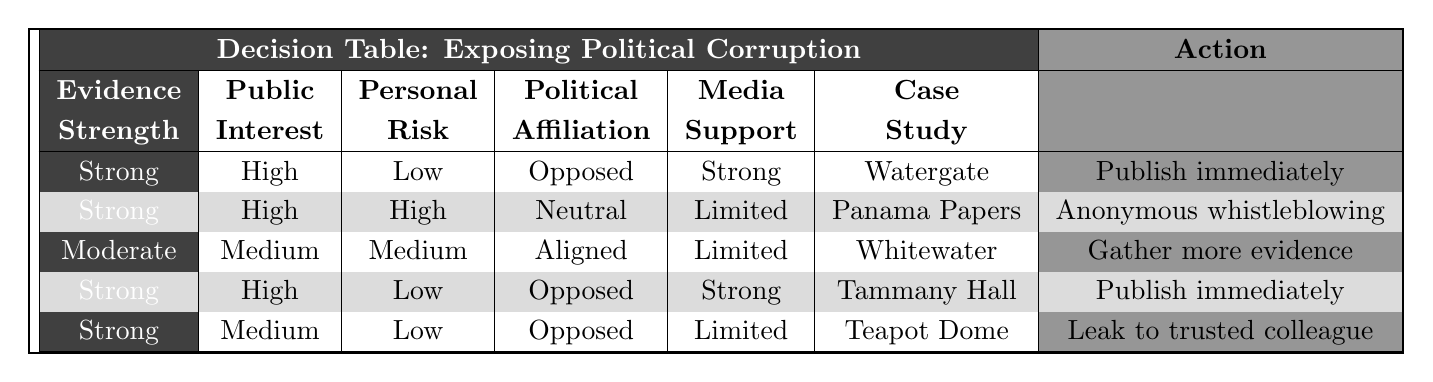What action is suggested for strong evidence, high public interest, and low personal risk with an opposed political affiliation and strong media support? According to the table, the conditions for the desired action are matched in the first row, which indicates that the action suggested in this case is to publish immediately.
Answer: Publish immediately Is the action for moderate evidence, medium public interest, and medium personal risk with aligned political affiliation and limited media support to gather more evidence? The table clearly shows that the action corresponding to these conditions is "Gather more evidence," found in the third row.
Answer: Yes How many actions are suggested for weak evidence, low public interest, and high personal risk with opposed political affiliation and no media support? Review the table and identify the row under the weak evidence conditions. Only one action—"Shelve the story"—was found to be relevant for these specific conditions.
Answer: One What actions are presented for cases with high public interest? The rows with high public interest are the first, second, fourth, and fifth cases. Analyzing these, the actions suggested are "Publish immediately," "Anonymous whistleblowing," and "Shelve the story." Counting these gives us three distinct actions.
Answer: Three What is the action when there's strong evidence, high public interest, high personal risk, aligned political affiliation, and no media support? The table indicates that the specific conditions for this scenario lead to the action of leaking to a trusted colleague, derived from the second row.
Answer: Leak to trusted colleague Are there any cases listed with a political affiliation that is neutral? When checking the table, the conditions that show a neutral political affiliation include the second and third rows. Since such cases do exist, the answer is yes.
Answer: Yes What is the average number of actions given for cases with strong evidence? There are four rows represented with strong evidence: the first, second, fourth, and fifth rows, with actions of "Publish immediately," "Anonymous whistleblowing," and "Leak to trusted colleague." Thus, the average number of actions for cases with strong evidence is three.
Answer: Three Is the action for weak evidence, medium public interest, and medium personal risk with an aligned political affiliation and limited media support to publish immediately? After analyzing the conditions listed, the relevant action associated with these parameters is actually to gather more evidence, which indicates that the statement is false.
Answer: No 